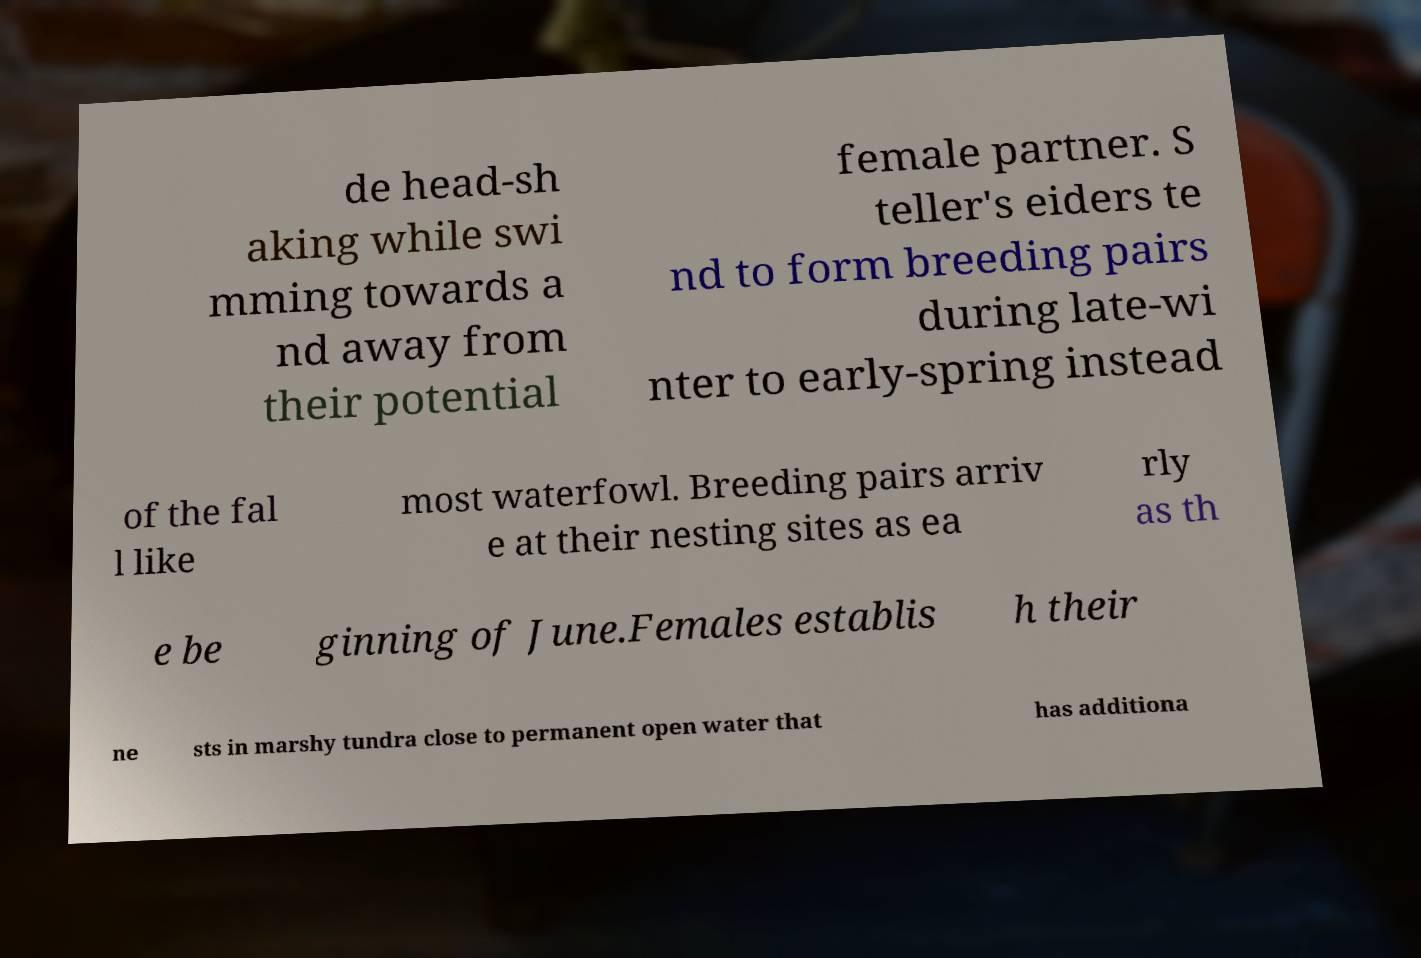Could you assist in decoding the text presented in this image and type it out clearly? de head-sh aking while swi mming towards a nd away from their potential female partner. S teller's eiders te nd to form breeding pairs during late-wi nter to early-spring instead of the fal l like most waterfowl. Breeding pairs arriv e at their nesting sites as ea rly as th e be ginning of June.Females establis h their ne sts in marshy tundra close to permanent open water that has additiona 